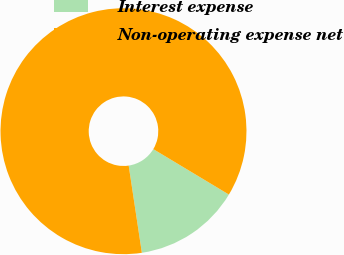Convert chart. <chart><loc_0><loc_0><loc_500><loc_500><pie_chart><fcel>Interest expense<fcel>Non-operating expense net<nl><fcel>14.0%<fcel>86.0%<nl></chart> 